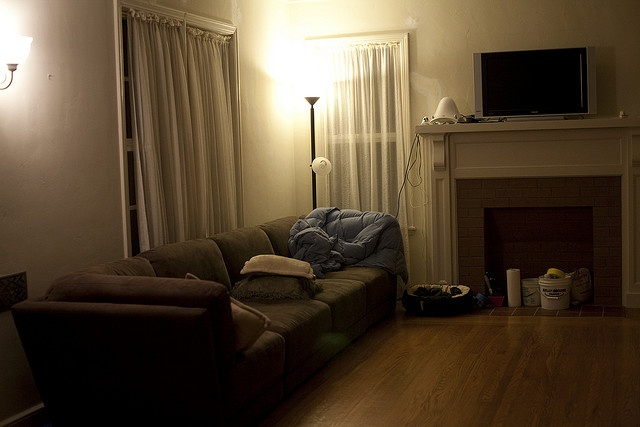Describe the objects in this image and their specific colors. I can see couch in ivory, black, maroon, and gray tones and tv in ivory, black, and gray tones in this image. 